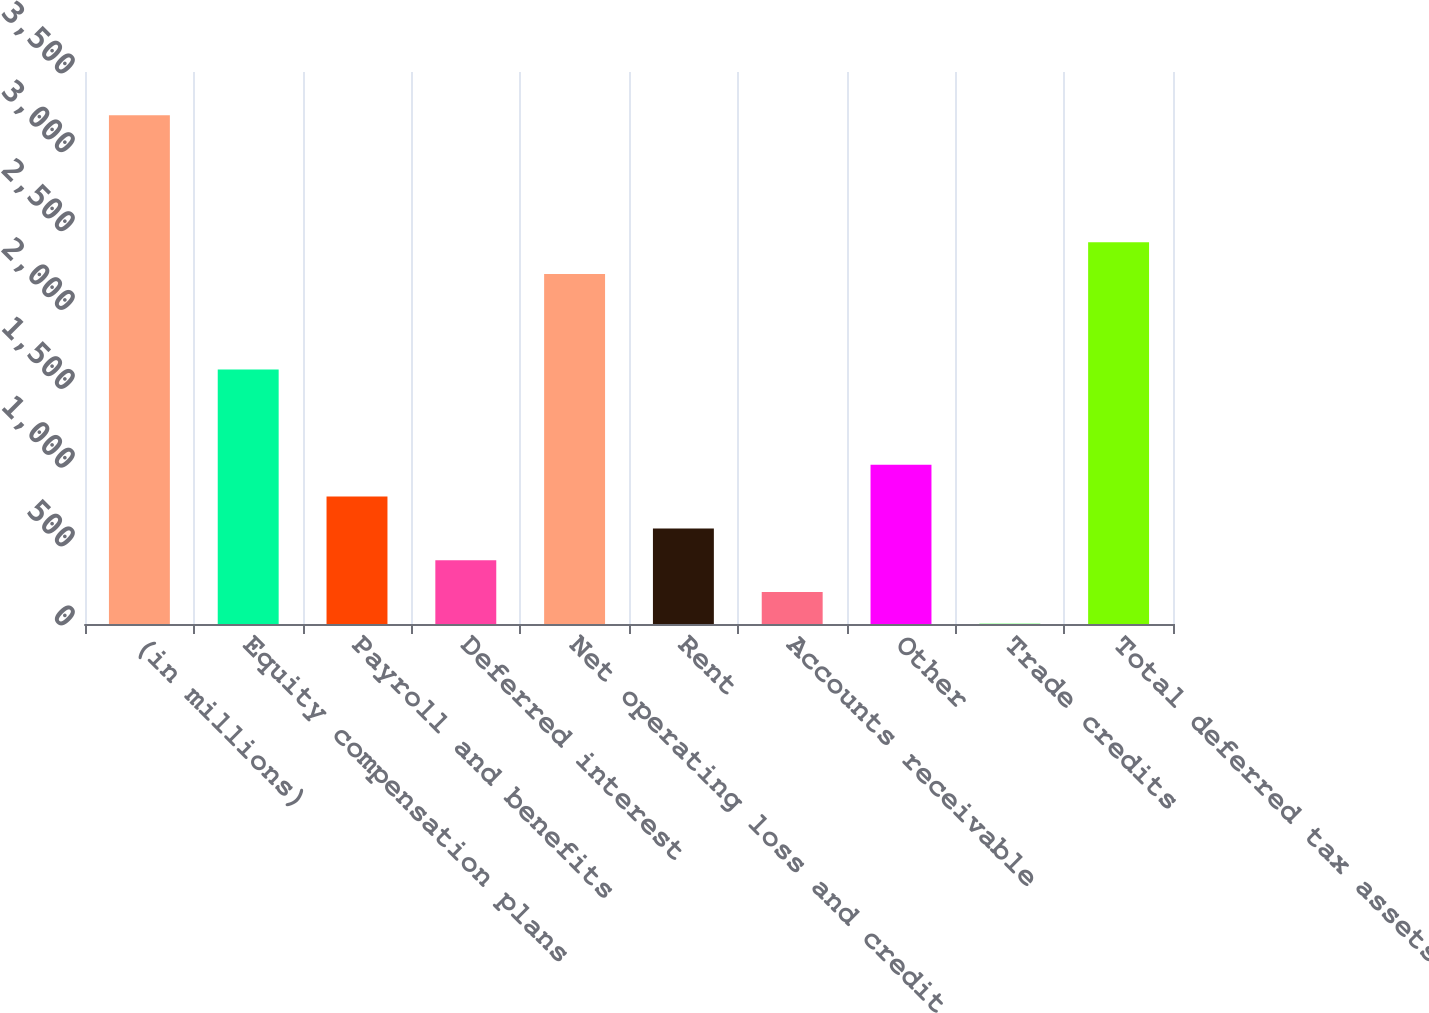Convert chart to OTSL. <chart><loc_0><loc_0><loc_500><loc_500><bar_chart><fcel>(in millions)<fcel>Equity compensation plans<fcel>Payroll and benefits<fcel>Deferred interest<fcel>Net operating loss and credit<fcel>Rent<fcel>Accounts receivable<fcel>Other<fcel>Trade credits<fcel>Total deferred tax assets<nl><fcel>3226.3<fcel>1613.9<fcel>807.7<fcel>404.6<fcel>2218.55<fcel>606.15<fcel>203.05<fcel>1009.25<fcel>1.5<fcel>2420.1<nl></chart> 